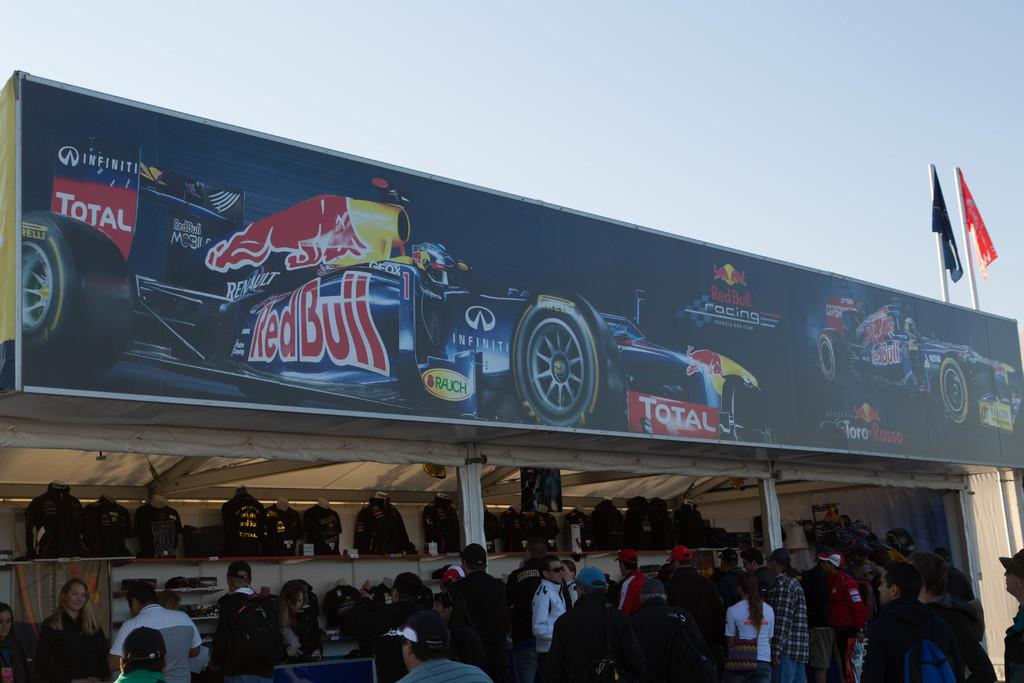What can be seen in the sky in the image? The sky is visible in the image. What objects are related to flags in the image? There are flags and flag posts in the image. What type of signage is present in the image? There is an advertisement board in the image. What type of figures are present in the image? Mannequins are present in the image. Are there any people visible in the image? Yes, there are persons standing on the floor in the image. How much salt is on the floor in the image? There is no salt visible on the floor in the image. What type of parent is present in the image? There are no parents present in the image; it features flags, flag posts, an advertisement board, mannequins, and persons. 